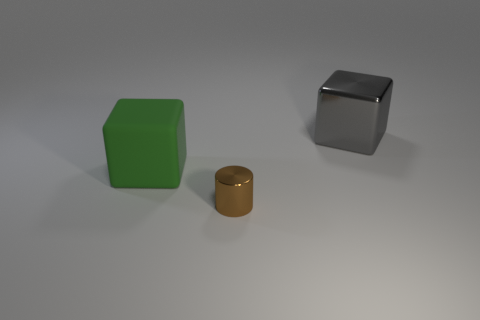Are there any objects that are left of the metal object that is on the right side of the brown object?
Offer a terse response. Yes. Is there any other thing that is made of the same material as the big green block?
Keep it short and to the point. No. Is the shape of the big gray metal thing the same as the metallic thing in front of the green block?
Your response must be concise. No. What number of other objects are the same size as the brown metal object?
Your answer should be very brief. 0. What number of yellow objects are metal cubes or cylinders?
Ensure brevity in your answer.  0. How many things are in front of the green thing and behind the brown shiny thing?
Give a very brief answer. 0. The large thing to the left of the shiny thing on the left side of the cube behind the large green cube is made of what material?
Ensure brevity in your answer.  Rubber. How many other objects are made of the same material as the green thing?
Your answer should be compact. 0. What shape is the gray shiny thing that is the same size as the matte object?
Ensure brevity in your answer.  Cube. Are there any large green blocks to the left of the small brown cylinder?
Provide a succinct answer. Yes. 